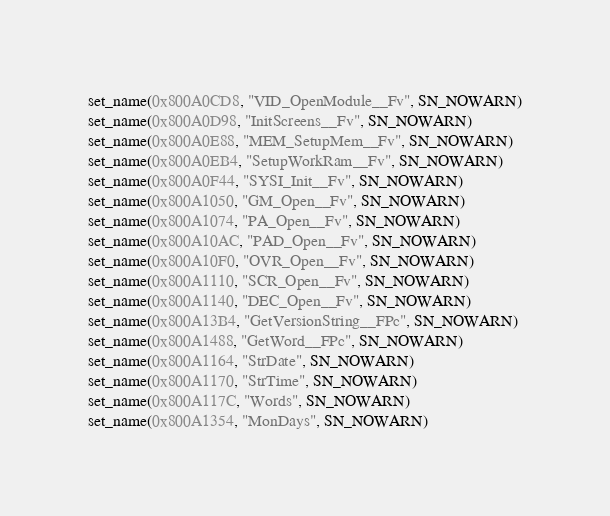<code> <loc_0><loc_0><loc_500><loc_500><_Python_>set_name(0x800A0CD8, "VID_OpenModule__Fv", SN_NOWARN)
set_name(0x800A0D98, "InitScreens__Fv", SN_NOWARN)
set_name(0x800A0E88, "MEM_SetupMem__Fv", SN_NOWARN)
set_name(0x800A0EB4, "SetupWorkRam__Fv", SN_NOWARN)
set_name(0x800A0F44, "SYSI_Init__Fv", SN_NOWARN)
set_name(0x800A1050, "GM_Open__Fv", SN_NOWARN)
set_name(0x800A1074, "PA_Open__Fv", SN_NOWARN)
set_name(0x800A10AC, "PAD_Open__Fv", SN_NOWARN)
set_name(0x800A10F0, "OVR_Open__Fv", SN_NOWARN)
set_name(0x800A1110, "SCR_Open__Fv", SN_NOWARN)
set_name(0x800A1140, "DEC_Open__Fv", SN_NOWARN)
set_name(0x800A13B4, "GetVersionString__FPc", SN_NOWARN)
set_name(0x800A1488, "GetWord__FPc", SN_NOWARN)
set_name(0x800A1164, "StrDate", SN_NOWARN)
set_name(0x800A1170, "StrTime", SN_NOWARN)
set_name(0x800A117C, "Words", SN_NOWARN)
set_name(0x800A1354, "MonDays", SN_NOWARN)
</code> 